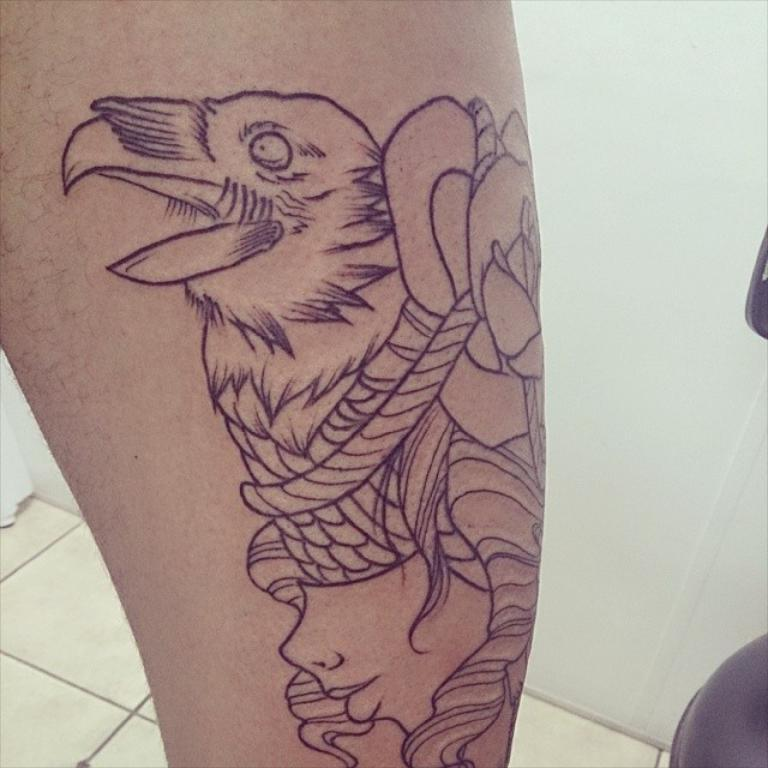What can be seen on the person's body in the image? There is a tattoo on a person's body in the image. What is visible in the background of the image? There is a wall in the background of the image. What object is on the right side of the image? There is a chair on the right side of the image. What page of the book is the person talking about in the image? There is no book or talking person present in the image. 